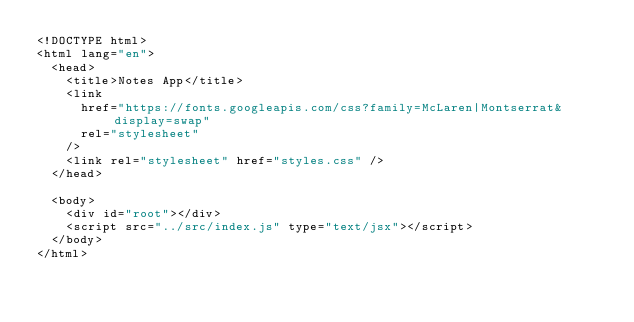Convert code to text. <code><loc_0><loc_0><loc_500><loc_500><_HTML_><!DOCTYPE html>
<html lang="en">
  <head>
    <title>Notes App</title>
    <link
      href="https://fonts.googleapis.com/css?family=McLaren|Montserrat&display=swap"
      rel="stylesheet"
    />
    <link rel="stylesheet" href="styles.css" />
  </head>

  <body>
    <div id="root"></div>
    <script src="../src/index.js" type="text/jsx"></script>
  </body>
</html>
</code> 